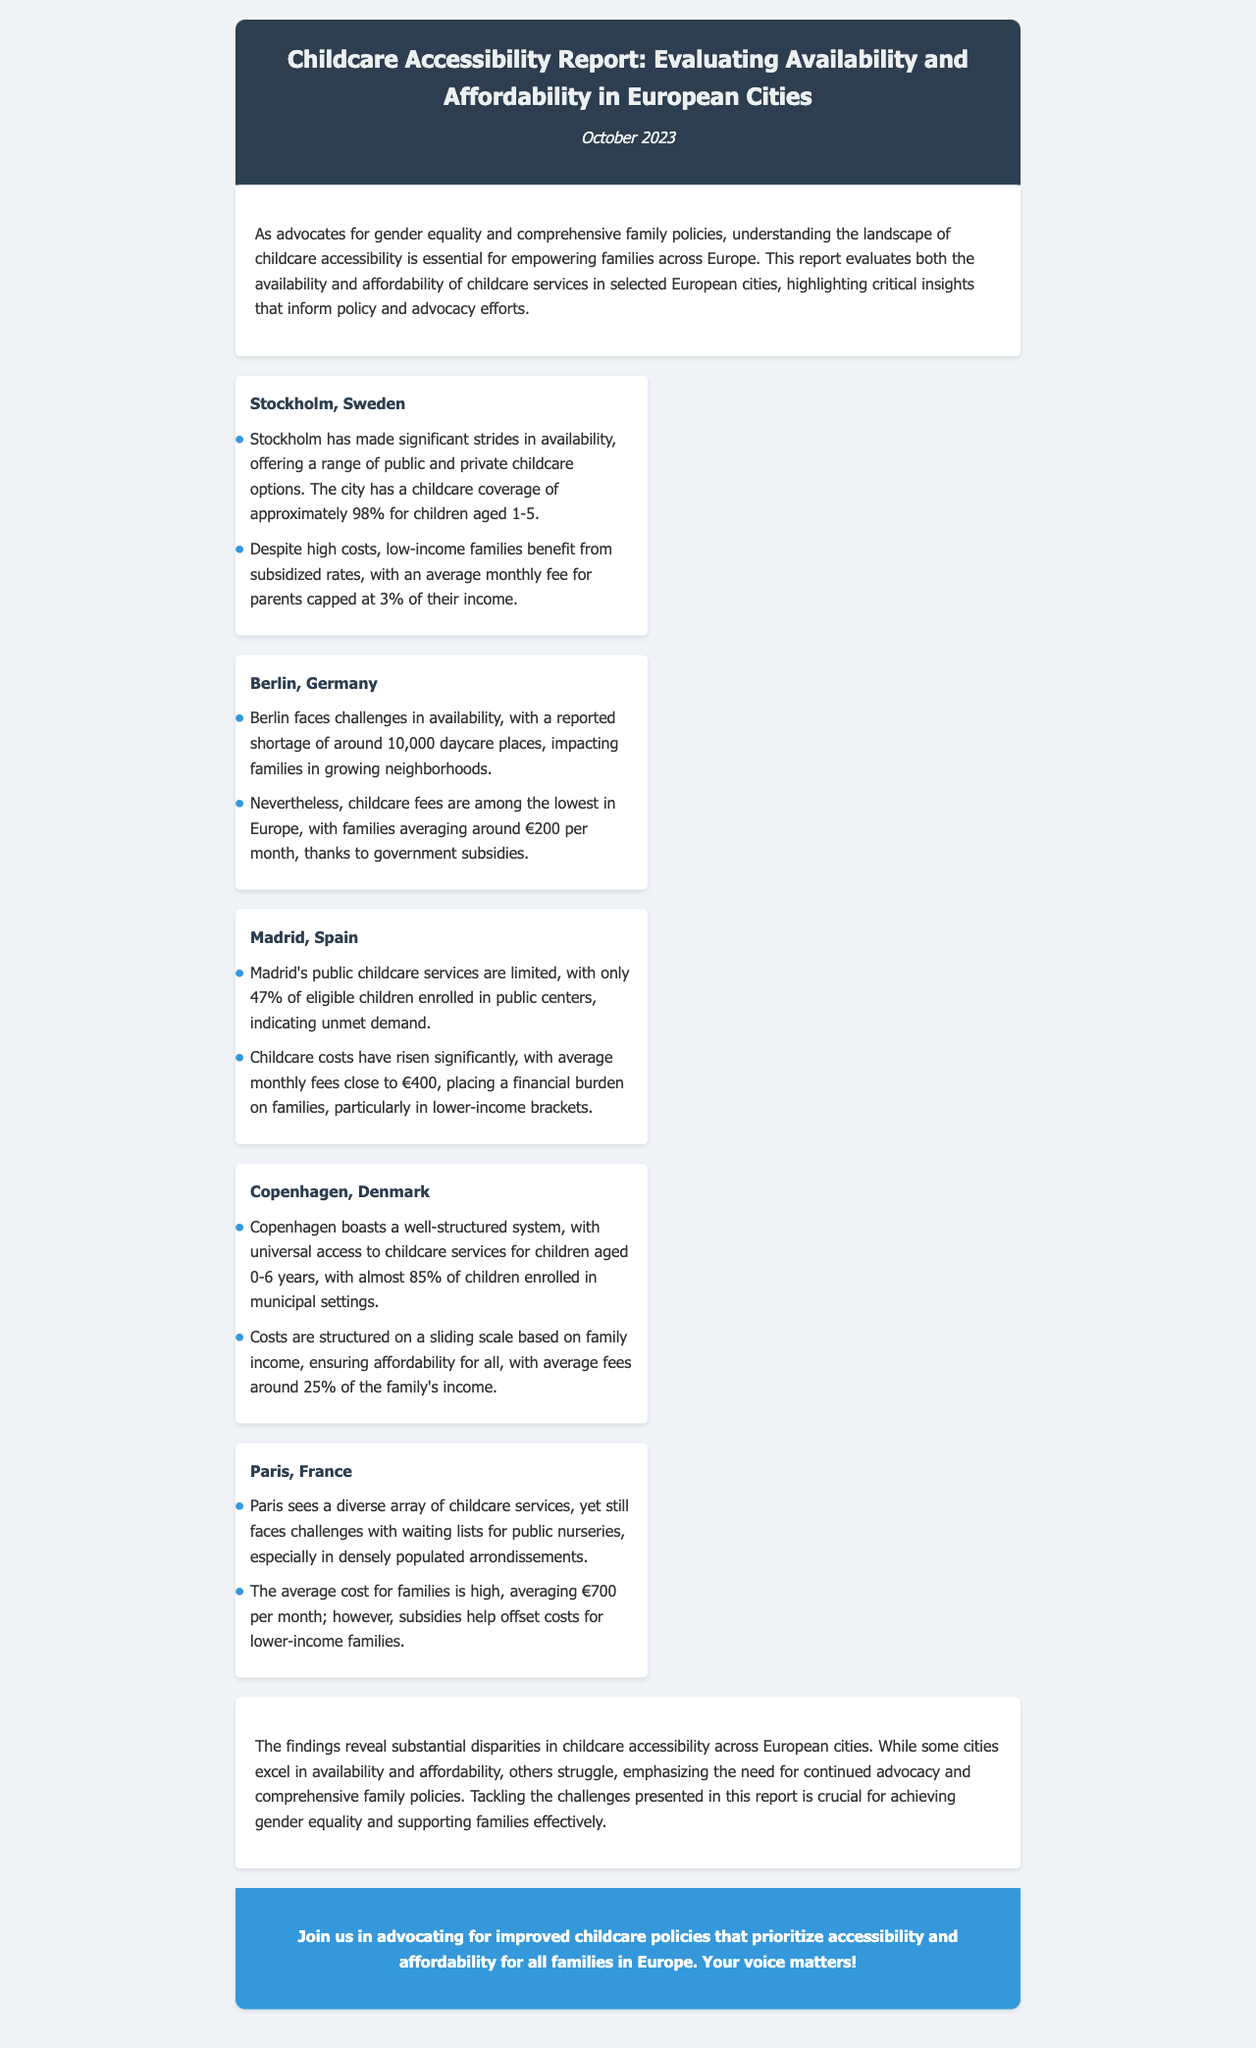What is the childcare coverage percentage in Stockholm? The childcare coverage in Stockholm is approximately 98% for children aged 1-5.
Answer: 98% How many daycare places are reported as short in Berlin? Berlin is reported to have a shortage of around 10,000 daycare places.
Answer: 10,000 What is the average monthly childcare fee in Madrid? The average monthly childcare fees in Madrid are close to €400.
Answer: €400 What percentage of children are enrolled in municipal settings in Copenhagen? Almost 85% of children in Copenhagen are enrolled in municipal settings.
Answer: 85% What is the average cost for families utilizing childcare services in Paris? The average cost for families in Paris is high, averaging €700 per month.
Answer: €700 Which city faces challenges with waiting lists for public nurseries? Paris faces challenges with waiting lists for public nurseries.
Answer: Paris What common issue is highlighted for Madrid's public childcare services? Madrid's public childcare services are limited, indicating unmet demand.
Answer: Unmet demand What is emphasized as crucial for achieving gender equality? Tackling the challenges presented in this report is crucial for achieving gender equality.
Answer: Tackling challenges What percentage of families in Stockholm benefit from subsidized rates? The average monthly fee for parents in Stockholm is capped at 3% of their income.
Answer: 3% 